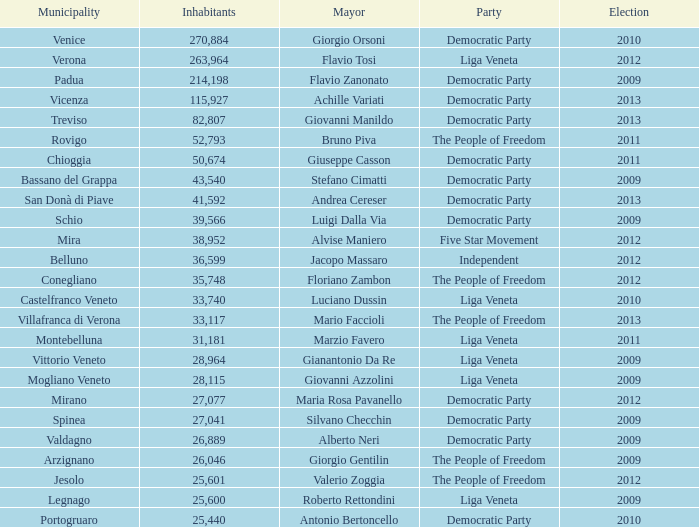In the election prior to 2012, how many residents had a five star movement party? None. 